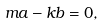<formula> <loc_0><loc_0><loc_500><loc_500>m a - k b = 0 ,</formula> 